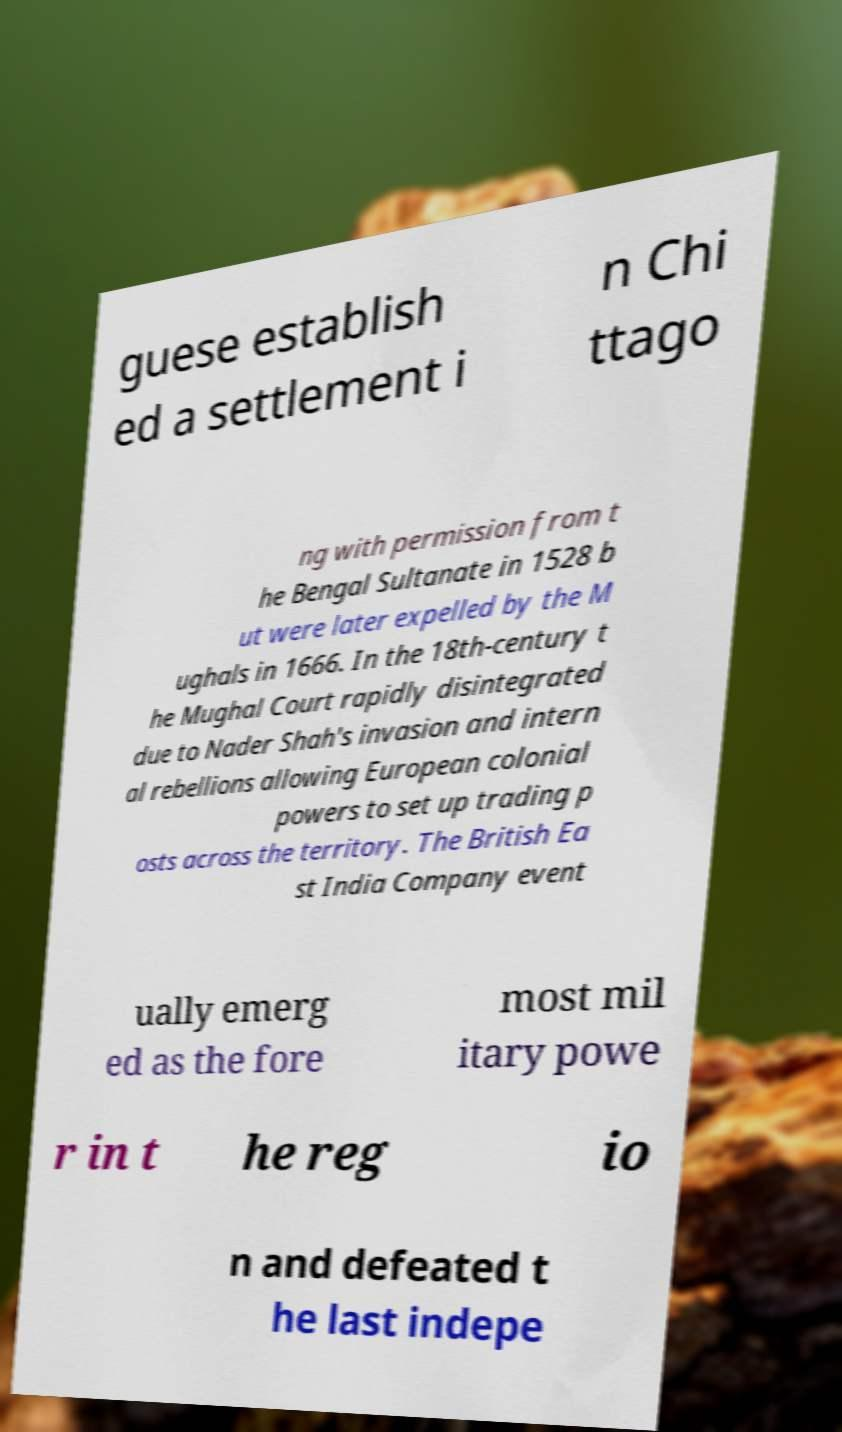There's text embedded in this image that I need extracted. Can you transcribe it verbatim? guese establish ed a settlement i n Chi ttago ng with permission from t he Bengal Sultanate in 1528 b ut were later expelled by the M ughals in 1666. In the 18th-century t he Mughal Court rapidly disintegrated due to Nader Shah's invasion and intern al rebellions allowing European colonial powers to set up trading p osts across the territory. The British Ea st India Company event ually emerg ed as the fore most mil itary powe r in t he reg io n and defeated t he last indepe 